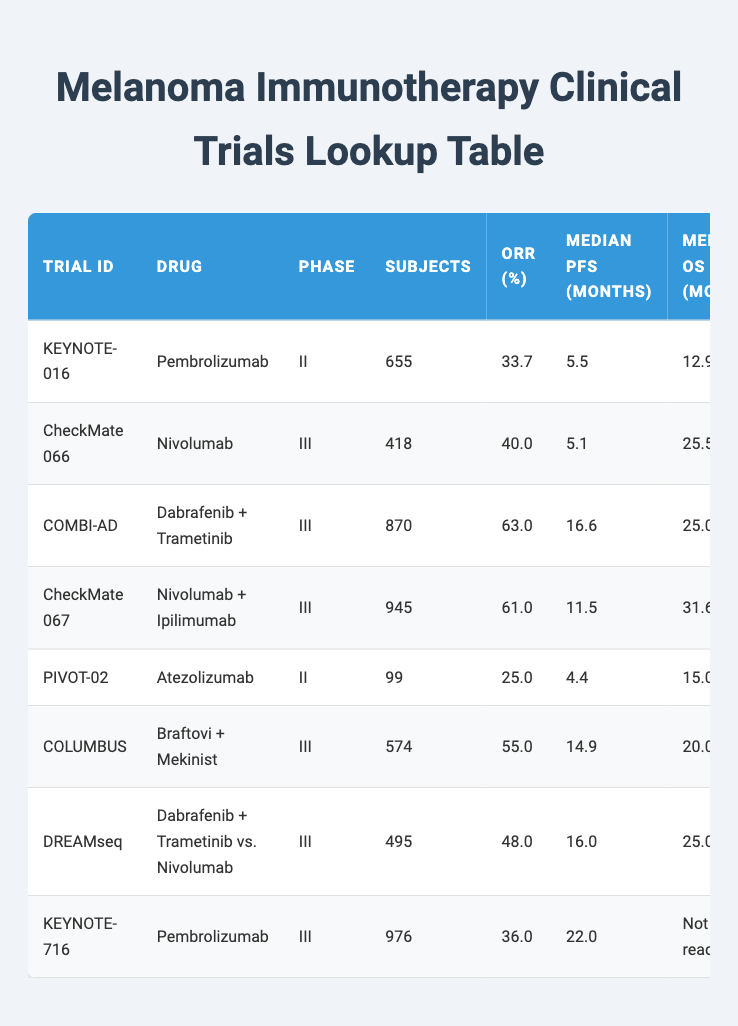What is the overall response rate for Pembrolizumab in the KEYNOTE-016 trial? The table shows that the overall response rate (ORR) for Pembrolizumab in the KEYNOTE-016 trial is listed as 33.7%.
Answer: 33.7% Which drug had the highest overall response rate in the trials listed? By examining the overall response rates in the table, Dabrafenib + Trametinib has the highest ORR at 63.0% in the COMBI-AD trial.
Answer: 63.0% How many subjects were involved in the CheckMate 067 trial? Looking at the CheckMate 067 row in the table, it shows that there were 945 subjects involved in this trial.
Answer: 945 What is the median progression-free survival for Atezolizumab in the PIVOT-02 trial? According to the table, the median progression-free survival (PFS) for Atezolizumab in the PIVOT-02 trial is 4.4 months.
Answer: 4.4 What is the difference in median overall survival between CheckMate 066 and CheckMate 067 trials? The median overall survival (OS) for CheckMate 066 is 25.5 months and for CheckMate 067 is 31.6 months. The difference is 31.6 - 25.5 = 6.1 months.
Answer: 6.1 Is the overall response rate of Nivolumab + Ipilimumab in CheckMate 067 higher than that of Atezolizumab in PIVOT-02? The ORR for Nivolumab + Ipilimumab in CheckMate 067 is 61.0%, while for Atezolizumab in PIVOT-02 it is 25.0%. Thus, yes, the ORR for CheckMate 067 is higher.
Answer: Yes What was the median progression-free survival for the trials conducted in 2017? The trials in 2017 are COMBI-AD and CheckMate 067, with median PFS of 16.6 and 11.5 months respectively. The average median PFS for both trials is (16.6 + 11.5) / 2 = 14.05 months.
Answer: 14.05 Which trial has the most subjects and what is that number? The trial with the most subjects is CheckMate 067 with 945 subjects. This can be confirmed by reviewing the subject count in each trial row.
Answer: 945 Was the median overall survival for KEYNOTE-716 reached or not? The table specifies that the median overall survival for KEYNOTE-716 is listed as "Not reached", indicating that data is not available to summarize this metric.
Answer: Not reached 